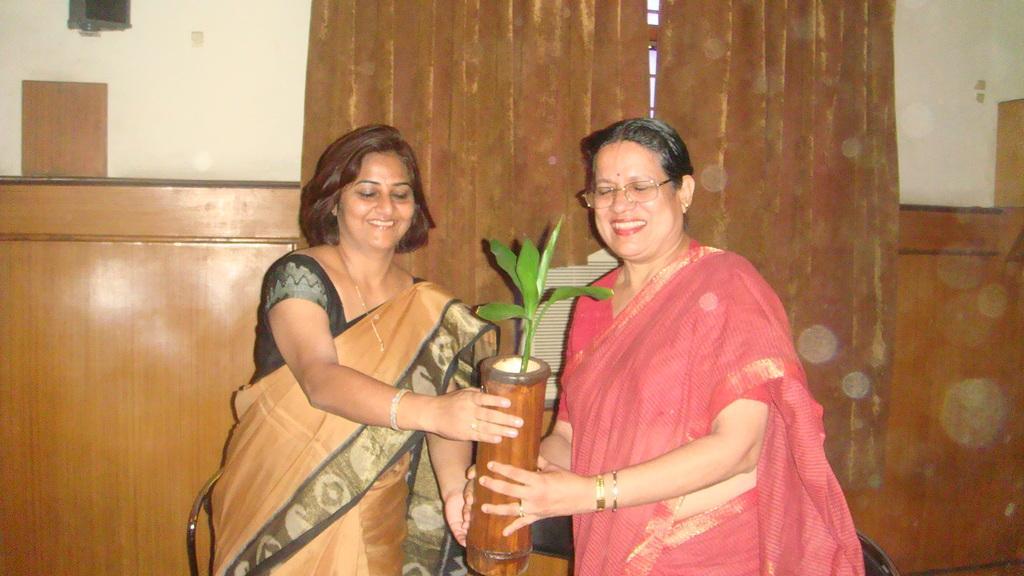Describe this image in one or two sentences. In this image in the foreground there are two women holding a flower pot, on which there is a plant, behind them there is a wall, curtain, wooden object. 